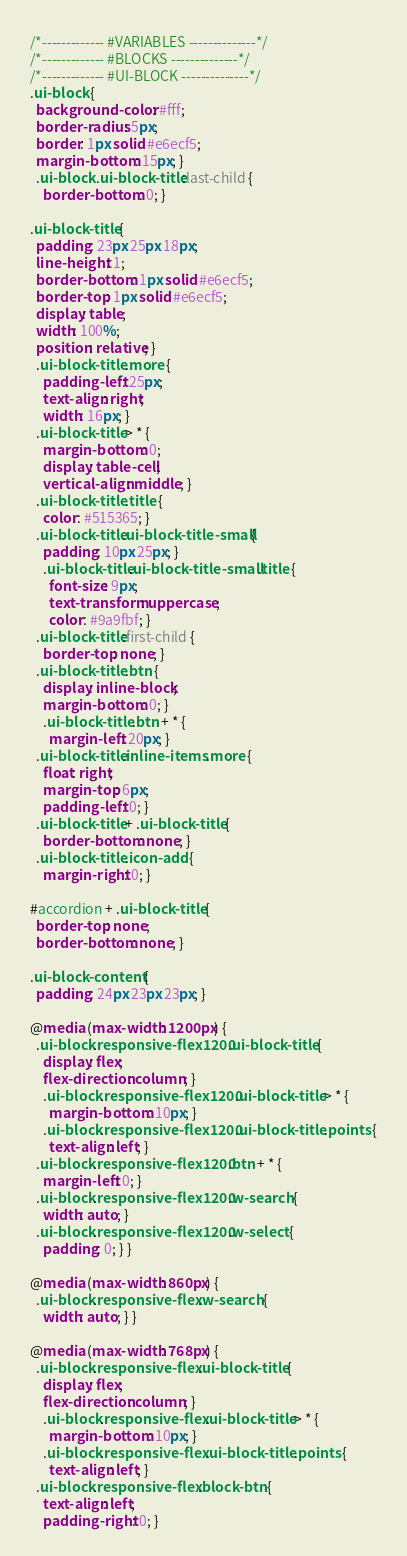<code> <loc_0><loc_0><loc_500><loc_500><_CSS_>/*------------- #VARIABLES --------------*/
/*------------- #BLOCKS --------------*/
/*------------- #UI-BLOCK --------------*/
.ui-block {
  background-color: #fff;
  border-radius: 5px;
  border: 1px solid #e6ecf5;
  margin-bottom: 15px; }
  .ui-block .ui-block-title:last-child {
    border-bottom: 0; }

.ui-block-title {
  padding: 23px 25px 18px;
  line-height: 1;
  border-bottom: 1px solid #e6ecf5;
  border-top: 1px solid #e6ecf5;
  display: table;
  width: 100%;
  position: relative; }
  .ui-block-title .more {
    padding-left: 25px;
    text-align: right;
    width: 16px; }
  .ui-block-title > * {
    margin-bottom: 0;
    display: table-cell;
    vertical-align: middle; }
  .ui-block-title .title {
    color: #515365; }
  .ui-block-title.ui-block-title-small {
    padding: 10px 25px; }
    .ui-block-title.ui-block-title-small .title {
      font-size: 9px;
      text-transform: uppercase;
      color: #9a9fbf; }
  .ui-block-title:first-child {
    border-top: none; }
  .ui-block-title .btn {
    display: inline-block;
    margin-bottom: 0; }
    .ui-block-title .btn + * {
      margin-left: 20px; }
  .ui-block-title.inline-items .more {
    float: right;
    margin-top: 6px;
    padding-left: 0; }
  .ui-block-title + .ui-block-title {
    border-bottom: none; }
  .ui-block-title .icon-add {
    margin-right: 0; }

#accordion + .ui-block-title {
  border-top: none;
  border-bottom: none; }

.ui-block-content {
  padding: 24px 23px 23px; }

@media (max-width: 1200px) {
  .ui-block.responsive-flex1200 .ui-block-title {
    display: flex;
    flex-direction: column; }
    .ui-block.responsive-flex1200 .ui-block-title > * {
      margin-bottom: 10px; }
    .ui-block.responsive-flex1200 .ui-block-title .points {
      text-align: left; }
  .ui-block.responsive-flex1200 .btn + * {
    margin-left: 0; }
  .ui-block.responsive-flex1200 .w-search {
    width: auto; }
  .ui-block.responsive-flex1200 .w-select {
    padding: 0; } }

@media (max-width: 860px) {
  .ui-block.responsive-flex .w-search {
    width: auto; } }

@media (max-width: 768px) {
  .ui-block.responsive-flex .ui-block-title {
    display: flex;
    flex-direction: column; }
    .ui-block.responsive-flex .ui-block-title > * {
      margin-bottom: 10px; }
    .ui-block.responsive-flex .ui-block-title .points {
      text-align: left; }
  .ui-block.responsive-flex .block-btn {
    text-align: left;
    padding-right: 0; }</code> 